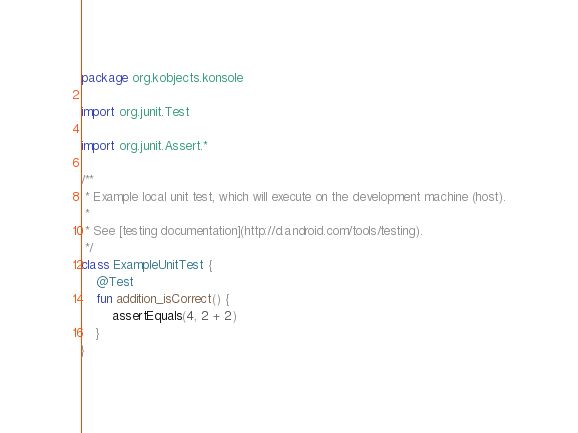Convert code to text. <code><loc_0><loc_0><loc_500><loc_500><_Kotlin_>package org.kobjects.konsole

import org.junit.Test

import org.junit.Assert.*

/**
 * Example local unit test, which will execute on the development machine (host).
 *
 * See [testing documentation](http://d.android.com/tools/testing).
 */
class ExampleUnitTest {
    @Test
    fun addition_isCorrect() {
        assertEquals(4, 2 + 2)
    }
}</code> 